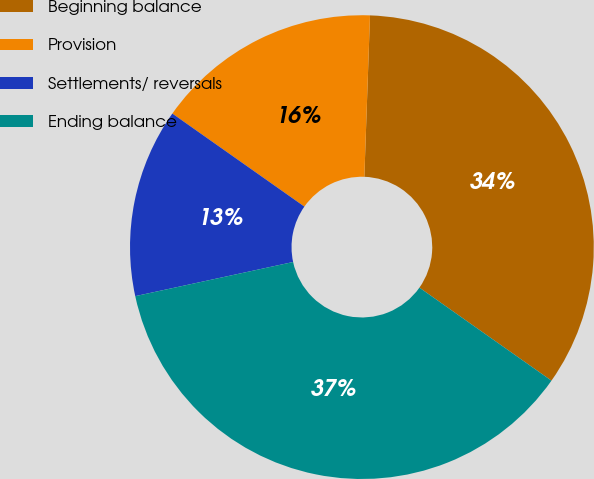Convert chart to OTSL. <chart><loc_0><loc_0><loc_500><loc_500><pie_chart><fcel>Beginning balance<fcel>Provision<fcel>Settlements/ reversals<fcel>Ending balance<nl><fcel>34.21%<fcel>15.79%<fcel>13.16%<fcel>36.84%<nl></chart> 